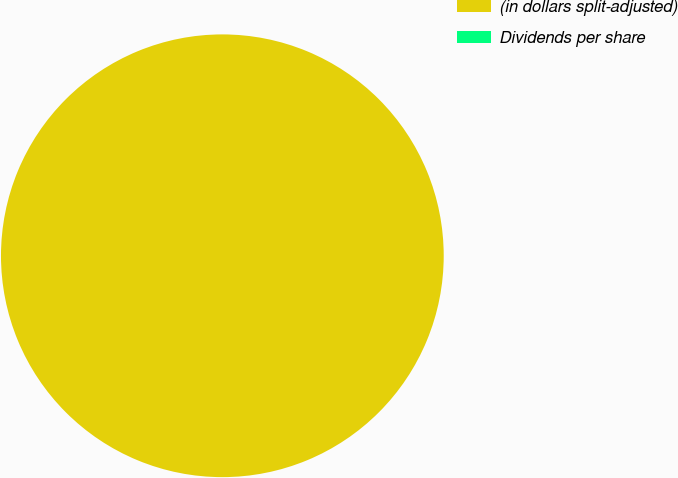Convert chart. <chart><loc_0><loc_0><loc_500><loc_500><pie_chart><fcel>(in dollars split-adjusted)<fcel>Dividends per share<nl><fcel>100.0%<fcel>0.0%<nl></chart> 